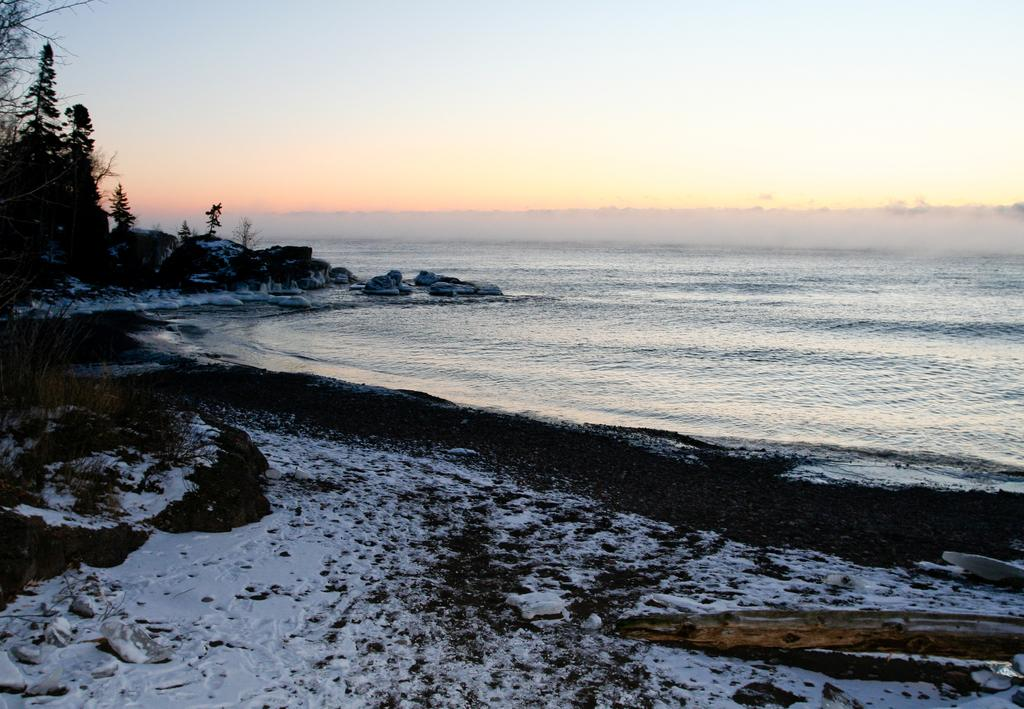What is visible in the image? Water is visible in the image. What can be seen in the background of the image? There are trees in the background of the image. How would you describe the color of the sky in the image? The sky is blue and white in color. Where are the tomatoes growing in the image? There are no tomatoes present in the image. How much salt is dissolved in the water in the image? There is no information about salt in the image, as it only features water, trees, and the sky. 